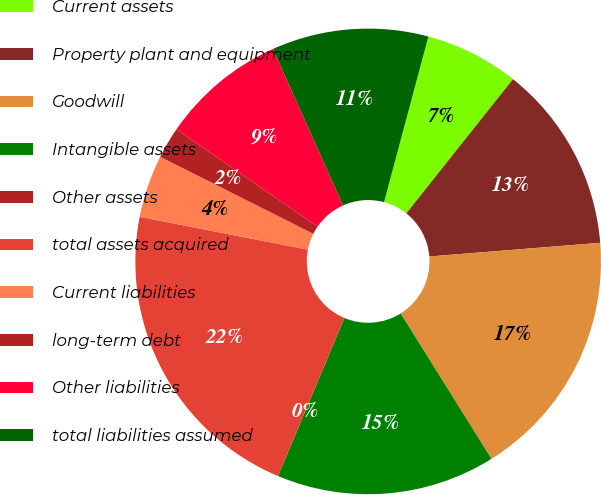Convert chart. <chart><loc_0><loc_0><loc_500><loc_500><pie_chart><fcel>Current assets<fcel>Property plant and equipment<fcel>Goodwill<fcel>Intangible assets<fcel>Other assets<fcel>total assets acquired<fcel>Current liabilities<fcel>long-term debt<fcel>Other liabilities<fcel>total liabilities assumed<nl><fcel>6.52%<fcel>13.04%<fcel>17.39%<fcel>15.21%<fcel>0.01%<fcel>21.73%<fcel>4.35%<fcel>2.18%<fcel>8.7%<fcel>10.87%<nl></chart> 